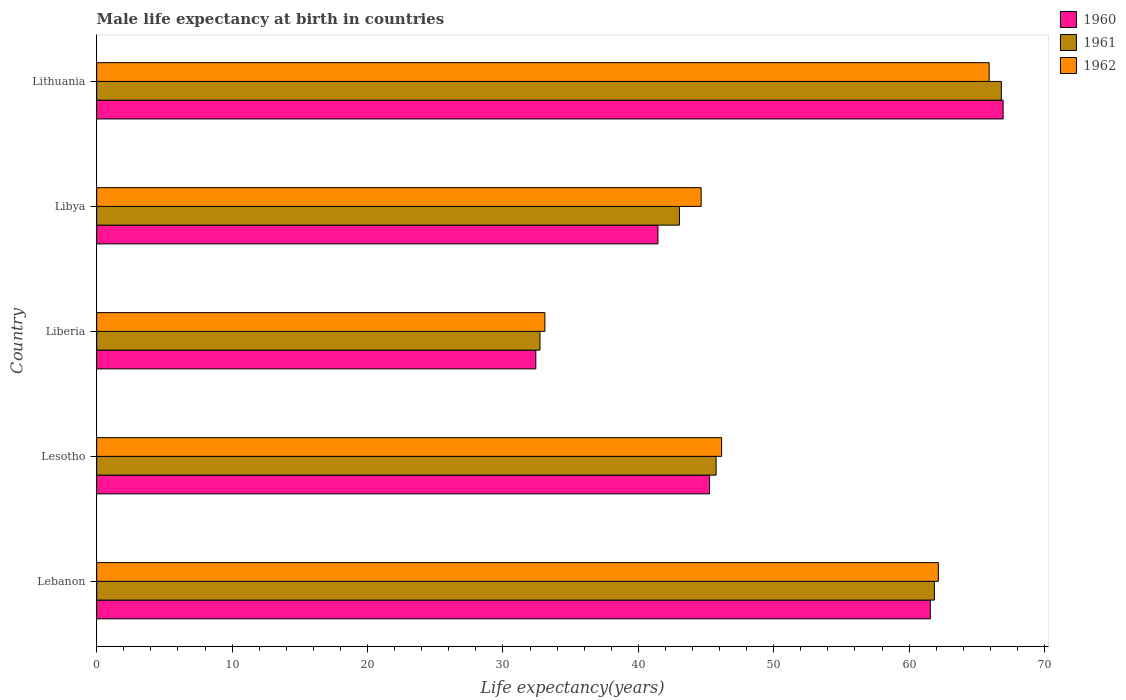Are the number of bars per tick equal to the number of legend labels?
Your response must be concise. Yes. Are the number of bars on each tick of the Y-axis equal?
Your answer should be very brief. Yes. How many bars are there on the 2nd tick from the bottom?
Your answer should be compact. 3. What is the label of the 2nd group of bars from the top?
Offer a terse response. Libya. What is the male life expectancy at birth in 1961 in Lebanon?
Keep it short and to the point. 61.87. Across all countries, what is the maximum male life expectancy at birth in 1962?
Make the answer very short. 65.91. Across all countries, what is the minimum male life expectancy at birth in 1962?
Keep it short and to the point. 33.1. In which country was the male life expectancy at birth in 1962 maximum?
Your response must be concise. Lithuania. In which country was the male life expectancy at birth in 1962 minimum?
Make the answer very short. Liberia. What is the total male life expectancy at birth in 1960 in the graph?
Make the answer very short. 247.64. What is the difference between the male life expectancy at birth in 1962 in Lebanon and that in Lithuania?
Keep it short and to the point. -3.75. What is the difference between the male life expectancy at birth in 1960 in Liberia and the male life expectancy at birth in 1962 in Lithuania?
Your answer should be compact. -33.48. What is the average male life expectancy at birth in 1962 per country?
Give a very brief answer. 50.39. What is the difference between the male life expectancy at birth in 1962 and male life expectancy at birth in 1960 in Lebanon?
Keep it short and to the point. 0.59. What is the ratio of the male life expectancy at birth in 1961 in Libya to that in Lithuania?
Offer a very short reply. 0.64. What is the difference between the highest and the second highest male life expectancy at birth in 1962?
Your response must be concise. 3.75. What is the difference between the highest and the lowest male life expectancy at birth in 1962?
Make the answer very short. 32.81. Is the sum of the male life expectancy at birth in 1962 in Lebanon and Lithuania greater than the maximum male life expectancy at birth in 1960 across all countries?
Ensure brevity in your answer.  Yes. What does the 3rd bar from the top in Lebanon represents?
Keep it short and to the point. 1960. Is it the case that in every country, the sum of the male life expectancy at birth in 1962 and male life expectancy at birth in 1961 is greater than the male life expectancy at birth in 1960?
Your answer should be compact. Yes. How many bars are there?
Make the answer very short. 15. Are all the bars in the graph horizontal?
Offer a terse response. Yes. What is the difference between two consecutive major ticks on the X-axis?
Provide a short and direct response. 10. Does the graph contain grids?
Offer a very short reply. No. How many legend labels are there?
Provide a succinct answer. 3. What is the title of the graph?
Keep it short and to the point. Male life expectancy at birth in countries. What is the label or title of the X-axis?
Your answer should be compact. Life expectancy(years). What is the Life expectancy(years) in 1960 in Lebanon?
Provide a short and direct response. 61.56. What is the Life expectancy(years) of 1961 in Lebanon?
Make the answer very short. 61.87. What is the Life expectancy(years) in 1962 in Lebanon?
Your answer should be very brief. 62.16. What is the Life expectancy(years) in 1960 in Lesotho?
Offer a terse response. 45.26. What is the Life expectancy(years) of 1961 in Lesotho?
Your answer should be very brief. 45.74. What is the Life expectancy(years) of 1962 in Lesotho?
Provide a succinct answer. 46.15. What is the Life expectancy(years) of 1960 in Liberia?
Make the answer very short. 32.43. What is the Life expectancy(years) in 1961 in Liberia?
Give a very brief answer. 32.74. What is the Life expectancy(years) of 1962 in Liberia?
Ensure brevity in your answer.  33.1. What is the Life expectancy(years) of 1960 in Libya?
Your response must be concise. 41.45. What is the Life expectancy(years) in 1961 in Libya?
Offer a very short reply. 43.03. What is the Life expectancy(years) of 1962 in Libya?
Give a very brief answer. 44.64. What is the Life expectancy(years) of 1960 in Lithuania?
Make the answer very short. 66.94. What is the Life expectancy(years) of 1961 in Lithuania?
Your answer should be compact. 66.81. What is the Life expectancy(years) in 1962 in Lithuania?
Your answer should be compact. 65.91. Across all countries, what is the maximum Life expectancy(years) in 1960?
Provide a short and direct response. 66.94. Across all countries, what is the maximum Life expectancy(years) in 1961?
Your answer should be compact. 66.81. Across all countries, what is the maximum Life expectancy(years) in 1962?
Keep it short and to the point. 65.91. Across all countries, what is the minimum Life expectancy(years) in 1960?
Make the answer very short. 32.43. Across all countries, what is the minimum Life expectancy(years) in 1961?
Ensure brevity in your answer.  32.74. Across all countries, what is the minimum Life expectancy(years) in 1962?
Make the answer very short. 33.1. What is the total Life expectancy(years) in 1960 in the graph?
Keep it short and to the point. 247.64. What is the total Life expectancy(years) of 1961 in the graph?
Ensure brevity in your answer.  250.19. What is the total Life expectancy(years) in 1962 in the graph?
Your answer should be very brief. 251.96. What is the difference between the Life expectancy(years) in 1960 in Lebanon and that in Lesotho?
Offer a very short reply. 16.31. What is the difference between the Life expectancy(years) in 1961 in Lebanon and that in Lesotho?
Your answer should be compact. 16.12. What is the difference between the Life expectancy(years) of 1962 in Lebanon and that in Lesotho?
Ensure brevity in your answer.  16. What is the difference between the Life expectancy(years) in 1960 in Lebanon and that in Liberia?
Offer a very short reply. 29.14. What is the difference between the Life expectancy(years) of 1961 in Lebanon and that in Liberia?
Offer a very short reply. 29.13. What is the difference between the Life expectancy(years) of 1962 in Lebanon and that in Liberia?
Your answer should be very brief. 29.06. What is the difference between the Life expectancy(years) of 1960 in Lebanon and that in Libya?
Provide a short and direct response. 20.12. What is the difference between the Life expectancy(years) of 1961 in Lebanon and that in Libya?
Give a very brief answer. 18.83. What is the difference between the Life expectancy(years) of 1962 in Lebanon and that in Libya?
Your response must be concise. 17.52. What is the difference between the Life expectancy(years) of 1960 in Lebanon and that in Lithuania?
Ensure brevity in your answer.  -5.38. What is the difference between the Life expectancy(years) of 1961 in Lebanon and that in Lithuania?
Offer a terse response. -4.95. What is the difference between the Life expectancy(years) of 1962 in Lebanon and that in Lithuania?
Provide a short and direct response. -3.75. What is the difference between the Life expectancy(years) of 1960 in Lesotho and that in Liberia?
Ensure brevity in your answer.  12.83. What is the difference between the Life expectancy(years) in 1961 in Lesotho and that in Liberia?
Provide a short and direct response. 13.01. What is the difference between the Life expectancy(years) in 1962 in Lesotho and that in Liberia?
Make the answer very short. 13.05. What is the difference between the Life expectancy(years) in 1960 in Lesotho and that in Libya?
Give a very brief answer. 3.81. What is the difference between the Life expectancy(years) of 1961 in Lesotho and that in Libya?
Your answer should be very brief. 2.71. What is the difference between the Life expectancy(years) in 1962 in Lesotho and that in Libya?
Your answer should be compact. 1.51. What is the difference between the Life expectancy(years) in 1960 in Lesotho and that in Lithuania?
Offer a very short reply. -21.68. What is the difference between the Life expectancy(years) in 1961 in Lesotho and that in Lithuania?
Provide a succinct answer. -21.07. What is the difference between the Life expectancy(years) in 1962 in Lesotho and that in Lithuania?
Keep it short and to the point. -19.76. What is the difference between the Life expectancy(years) in 1960 in Liberia and that in Libya?
Keep it short and to the point. -9.02. What is the difference between the Life expectancy(years) of 1961 in Liberia and that in Libya?
Provide a succinct answer. -10.3. What is the difference between the Life expectancy(years) of 1962 in Liberia and that in Libya?
Make the answer very short. -11.54. What is the difference between the Life expectancy(years) of 1960 in Liberia and that in Lithuania?
Your response must be concise. -34.51. What is the difference between the Life expectancy(years) of 1961 in Liberia and that in Lithuania?
Provide a short and direct response. -34.07. What is the difference between the Life expectancy(years) in 1962 in Liberia and that in Lithuania?
Your answer should be compact. -32.81. What is the difference between the Life expectancy(years) of 1960 in Libya and that in Lithuania?
Your response must be concise. -25.49. What is the difference between the Life expectancy(years) of 1961 in Libya and that in Lithuania?
Your answer should be very brief. -23.78. What is the difference between the Life expectancy(years) in 1962 in Libya and that in Lithuania?
Your response must be concise. -21.27. What is the difference between the Life expectancy(years) of 1960 in Lebanon and the Life expectancy(years) of 1961 in Lesotho?
Ensure brevity in your answer.  15.82. What is the difference between the Life expectancy(years) in 1960 in Lebanon and the Life expectancy(years) in 1962 in Lesotho?
Your answer should be compact. 15.41. What is the difference between the Life expectancy(years) of 1961 in Lebanon and the Life expectancy(years) of 1962 in Lesotho?
Your response must be concise. 15.71. What is the difference between the Life expectancy(years) of 1960 in Lebanon and the Life expectancy(years) of 1961 in Liberia?
Give a very brief answer. 28.83. What is the difference between the Life expectancy(years) of 1960 in Lebanon and the Life expectancy(years) of 1962 in Liberia?
Offer a very short reply. 28.47. What is the difference between the Life expectancy(years) in 1961 in Lebanon and the Life expectancy(years) in 1962 in Liberia?
Your answer should be very brief. 28.77. What is the difference between the Life expectancy(years) in 1960 in Lebanon and the Life expectancy(years) in 1961 in Libya?
Your answer should be very brief. 18.53. What is the difference between the Life expectancy(years) in 1960 in Lebanon and the Life expectancy(years) in 1962 in Libya?
Provide a succinct answer. 16.93. What is the difference between the Life expectancy(years) of 1961 in Lebanon and the Life expectancy(years) of 1962 in Libya?
Your answer should be compact. 17.23. What is the difference between the Life expectancy(years) of 1960 in Lebanon and the Life expectancy(years) of 1961 in Lithuania?
Your answer should be very brief. -5.25. What is the difference between the Life expectancy(years) in 1960 in Lebanon and the Life expectancy(years) in 1962 in Lithuania?
Provide a succinct answer. -4.34. What is the difference between the Life expectancy(years) of 1961 in Lebanon and the Life expectancy(years) of 1962 in Lithuania?
Your answer should be very brief. -4.04. What is the difference between the Life expectancy(years) of 1960 in Lesotho and the Life expectancy(years) of 1961 in Liberia?
Offer a terse response. 12.52. What is the difference between the Life expectancy(years) of 1960 in Lesotho and the Life expectancy(years) of 1962 in Liberia?
Make the answer very short. 12.16. What is the difference between the Life expectancy(years) in 1961 in Lesotho and the Life expectancy(years) in 1962 in Liberia?
Your response must be concise. 12.64. What is the difference between the Life expectancy(years) of 1960 in Lesotho and the Life expectancy(years) of 1961 in Libya?
Provide a short and direct response. 2.23. What is the difference between the Life expectancy(years) of 1960 in Lesotho and the Life expectancy(years) of 1962 in Libya?
Make the answer very short. 0.62. What is the difference between the Life expectancy(years) of 1961 in Lesotho and the Life expectancy(years) of 1962 in Libya?
Your response must be concise. 1.1. What is the difference between the Life expectancy(years) in 1960 in Lesotho and the Life expectancy(years) in 1961 in Lithuania?
Give a very brief answer. -21.55. What is the difference between the Life expectancy(years) of 1960 in Lesotho and the Life expectancy(years) of 1962 in Lithuania?
Keep it short and to the point. -20.65. What is the difference between the Life expectancy(years) of 1961 in Lesotho and the Life expectancy(years) of 1962 in Lithuania?
Keep it short and to the point. -20.17. What is the difference between the Life expectancy(years) of 1960 in Liberia and the Life expectancy(years) of 1961 in Libya?
Offer a very short reply. -10.6. What is the difference between the Life expectancy(years) of 1960 in Liberia and the Life expectancy(years) of 1962 in Libya?
Your answer should be very brief. -12.21. What is the difference between the Life expectancy(years) of 1961 in Liberia and the Life expectancy(years) of 1962 in Libya?
Offer a terse response. -11.9. What is the difference between the Life expectancy(years) of 1960 in Liberia and the Life expectancy(years) of 1961 in Lithuania?
Your response must be concise. -34.38. What is the difference between the Life expectancy(years) in 1960 in Liberia and the Life expectancy(years) in 1962 in Lithuania?
Give a very brief answer. -33.48. What is the difference between the Life expectancy(years) in 1961 in Liberia and the Life expectancy(years) in 1962 in Lithuania?
Make the answer very short. -33.17. What is the difference between the Life expectancy(years) of 1960 in Libya and the Life expectancy(years) of 1961 in Lithuania?
Make the answer very short. -25.36. What is the difference between the Life expectancy(years) in 1960 in Libya and the Life expectancy(years) in 1962 in Lithuania?
Your answer should be compact. -24.46. What is the difference between the Life expectancy(years) in 1961 in Libya and the Life expectancy(years) in 1962 in Lithuania?
Offer a very short reply. -22.88. What is the average Life expectancy(years) of 1960 per country?
Provide a succinct answer. 49.53. What is the average Life expectancy(years) in 1961 per country?
Ensure brevity in your answer.  50.04. What is the average Life expectancy(years) of 1962 per country?
Make the answer very short. 50.39. What is the difference between the Life expectancy(years) in 1960 and Life expectancy(years) in 1961 in Lebanon?
Your answer should be very brief. -0.3. What is the difference between the Life expectancy(years) in 1960 and Life expectancy(years) in 1962 in Lebanon?
Your answer should be very brief. -0.59. What is the difference between the Life expectancy(years) of 1961 and Life expectancy(years) of 1962 in Lebanon?
Give a very brief answer. -0.29. What is the difference between the Life expectancy(years) of 1960 and Life expectancy(years) of 1961 in Lesotho?
Keep it short and to the point. -0.48. What is the difference between the Life expectancy(years) of 1960 and Life expectancy(years) of 1962 in Lesotho?
Provide a short and direct response. -0.89. What is the difference between the Life expectancy(years) in 1961 and Life expectancy(years) in 1962 in Lesotho?
Give a very brief answer. -0.41. What is the difference between the Life expectancy(years) in 1960 and Life expectancy(years) in 1961 in Liberia?
Your answer should be very brief. -0.31. What is the difference between the Life expectancy(years) of 1960 and Life expectancy(years) of 1962 in Liberia?
Provide a succinct answer. -0.67. What is the difference between the Life expectancy(years) in 1961 and Life expectancy(years) in 1962 in Liberia?
Provide a succinct answer. -0.36. What is the difference between the Life expectancy(years) in 1960 and Life expectancy(years) in 1961 in Libya?
Your response must be concise. -1.58. What is the difference between the Life expectancy(years) in 1960 and Life expectancy(years) in 1962 in Libya?
Provide a succinct answer. -3.19. What is the difference between the Life expectancy(years) in 1961 and Life expectancy(years) in 1962 in Libya?
Ensure brevity in your answer.  -1.6. What is the difference between the Life expectancy(years) in 1960 and Life expectancy(years) in 1961 in Lithuania?
Give a very brief answer. 0.13. What is the ratio of the Life expectancy(years) in 1960 in Lebanon to that in Lesotho?
Provide a short and direct response. 1.36. What is the ratio of the Life expectancy(years) in 1961 in Lebanon to that in Lesotho?
Provide a succinct answer. 1.35. What is the ratio of the Life expectancy(years) in 1962 in Lebanon to that in Lesotho?
Your answer should be compact. 1.35. What is the ratio of the Life expectancy(years) in 1960 in Lebanon to that in Liberia?
Your response must be concise. 1.9. What is the ratio of the Life expectancy(years) in 1961 in Lebanon to that in Liberia?
Your answer should be very brief. 1.89. What is the ratio of the Life expectancy(years) in 1962 in Lebanon to that in Liberia?
Give a very brief answer. 1.88. What is the ratio of the Life expectancy(years) of 1960 in Lebanon to that in Libya?
Give a very brief answer. 1.49. What is the ratio of the Life expectancy(years) of 1961 in Lebanon to that in Libya?
Ensure brevity in your answer.  1.44. What is the ratio of the Life expectancy(years) in 1962 in Lebanon to that in Libya?
Your answer should be compact. 1.39. What is the ratio of the Life expectancy(years) of 1960 in Lebanon to that in Lithuania?
Keep it short and to the point. 0.92. What is the ratio of the Life expectancy(years) in 1961 in Lebanon to that in Lithuania?
Make the answer very short. 0.93. What is the ratio of the Life expectancy(years) of 1962 in Lebanon to that in Lithuania?
Provide a short and direct response. 0.94. What is the ratio of the Life expectancy(years) in 1960 in Lesotho to that in Liberia?
Provide a succinct answer. 1.4. What is the ratio of the Life expectancy(years) of 1961 in Lesotho to that in Liberia?
Your response must be concise. 1.4. What is the ratio of the Life expectancy(years) of 1962 in Lesotho to that in Liberia?
Make the answer very short. 1.39. What is the ratio of the Life expectancy(years) of 1960 in Lesotho to that in Libya?
Your response must be concise. 1.09. What is the ratio of the Life expectancy(years) in 1961 in Lesotho to that in Libya?
Provide a short and direct response. 1.06. What is the ratio of the Life expectancy(years) of 1962 in Lesotho to that in Libya?
Make the answer very short. 1.03. What is the ratio of the Life expectancy(years) in 1960 in Lesotho to that in Lithuania?
Make the answer very short. 0.68. What is the ratio of the Life expectancy(years) of 1961 in Lesotho to that in Lithuania?
Keep it short and to the point. 0.68. What is the ratio of the Life expectancy(years) of 1962 in Lesotho to that in Lithuania?
Your answer should be compact. 0.7. What is the ratio of the Life expectancy(years) in 1960 in Liberia to that in Libya?
Your answer should be compact. 0.78. What is the ratio of the Life expectancy(years) of 1961 in Liberia to that in Libya?
Your response must be concise. 0.76. What is the ratio of the Life expectancy(years) in 1962 in Liberia to that in Libya?
Make the answer very short. 0.74. What is the ratio of the Life expectancy(years) of 1960 in Liberia to that in Lithuania?
Provide a short and direct response. 0.48. What is the ratio of the Life expectancy(years) of 1961 in Liberia to that in Lithuania?
Give a very brief answer. 0.49. What is the ratio of the Life expectancy(years) in 1962 in Liberia to that in Lithuania?
Your answer should be very brief. 0.5. What is the ratio of the Life expectancy(years) of 1960 in Libya to that in Lithuania?
Keep it short and to the point. 0.62. What is the ratio of the Life expectancy(years) in 1961 in Libya to that in Lithuania?
Offer a very short reply. 0.64. What is the ratio of the Life expectancy(years) of 1962 in Libya to that in Lithuania?
Offer a terse response. 0.68. What is the difference between the highest and the second highest Life expectancy(years) of 1960?
Your answer should be very brief. 5.38. What is the difference between the highest and the second highest Life expectancy(years) of 1961?
Ensure brevity in your answer.  4.95. What is the difference between the highest and the second highest Life expectancy(years) in 1962?
Your answer should be compact. 3.75. What is the difference between the highest and the lowest Life expectancy(years) in 1960?
Make the answer very short. 34.51. What is the difference between the highest and the lowest Life expectancy(years) in 1961?
Your response must be concise. 34.07. What is the difference between the highest and the lowest Life expectancy(years) of 1962?
Your answer should be very brief. 32.81. 